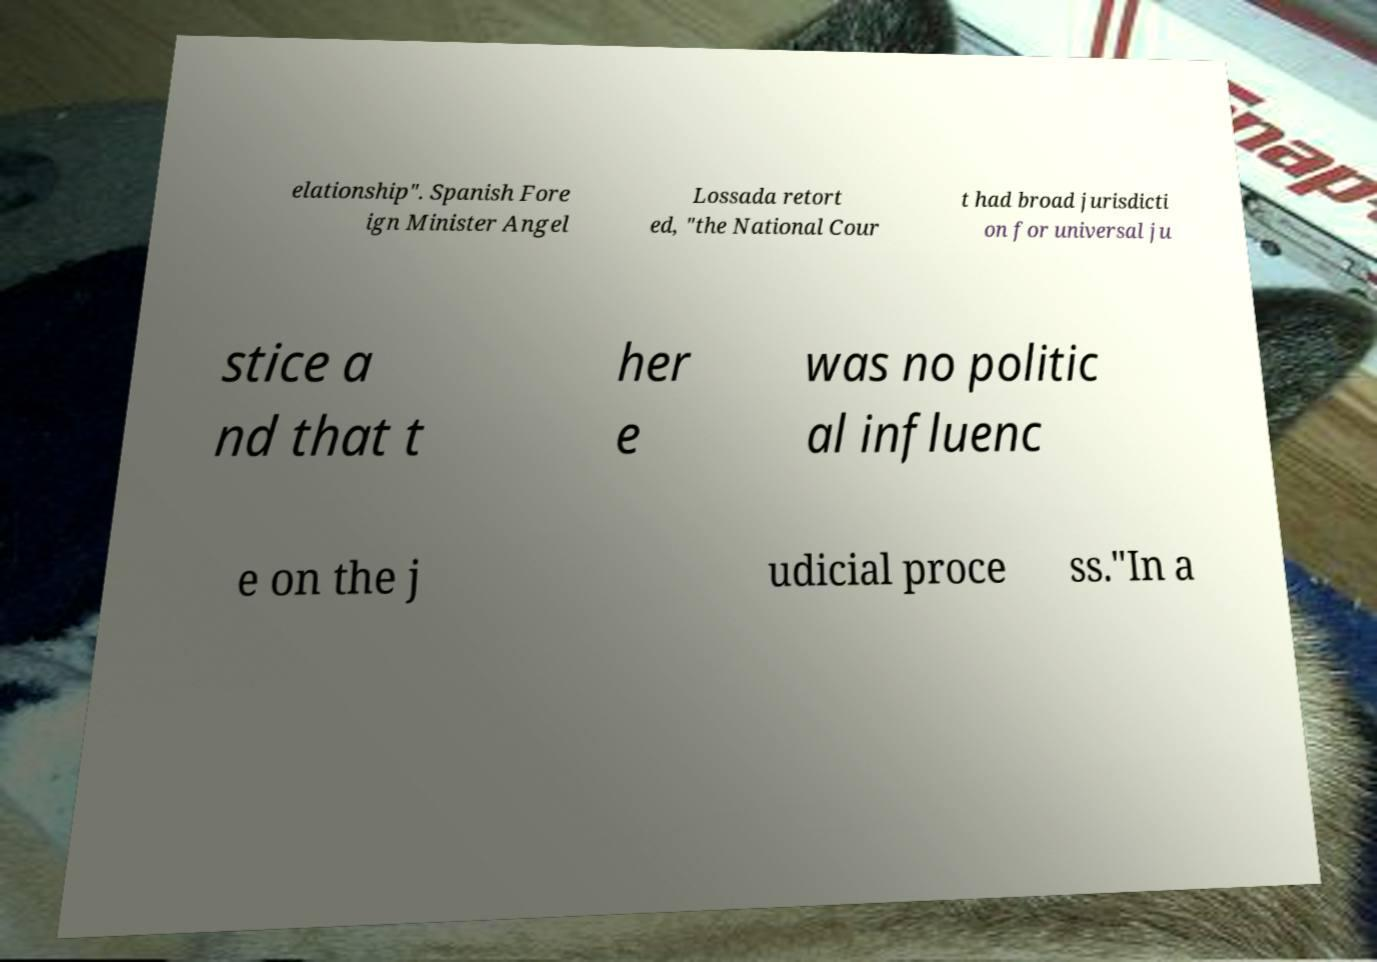What messages or text are displayed in this image? I need them in a readable, typed format. elationship". Spanish Fore ign Minister Angel Lossada retort ed, "the National Cour t had broad jurisdicti on for universal ju stice a nd that t her e was no politic al influenc e on the j udicial proce ss."In a 